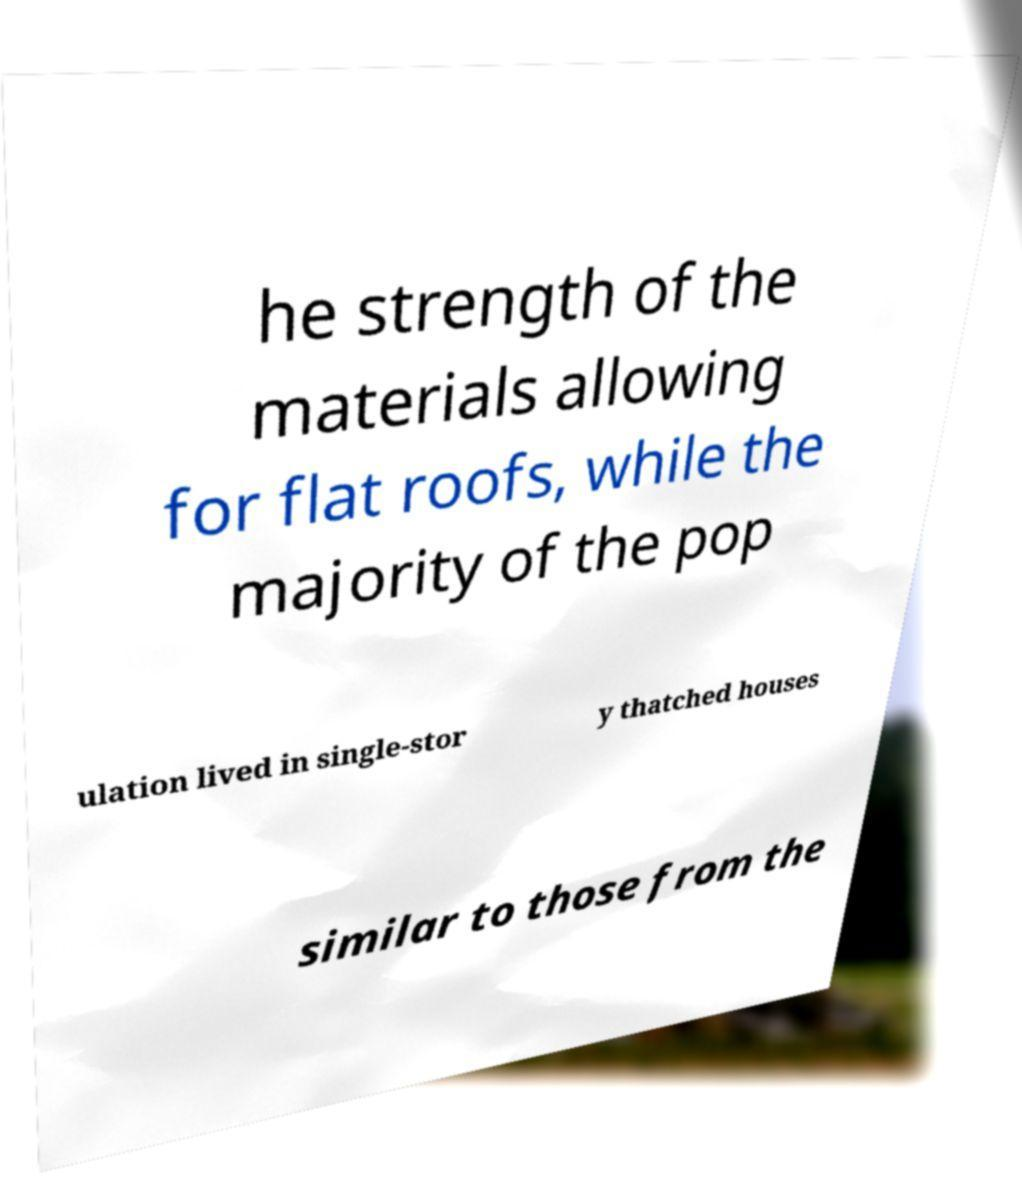Please read and relay the text visible in this image. What does it say? he strength of the materials allowing for flat roofs, while the majority of the pop ulation lived in single-stor y thatched houses similar to those from the 